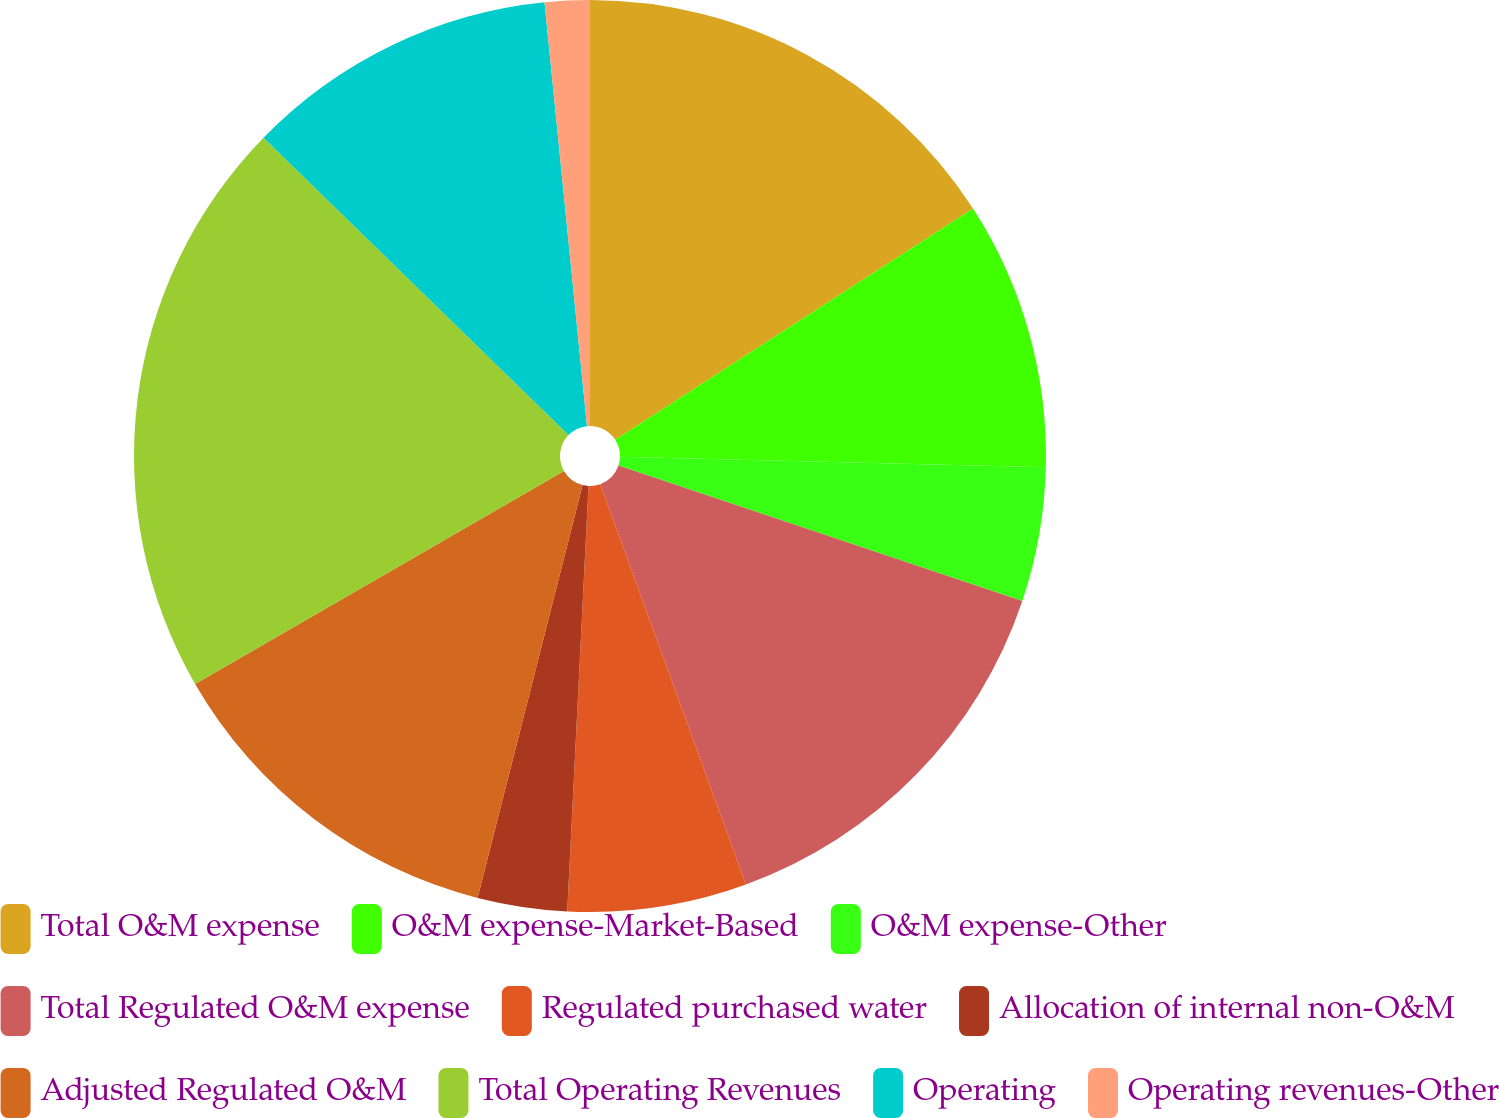<chart> <loc_0><loc_0><loc_500><loc_500><pie_chart><fcel>Total O&M expense<fcel>O&M expense-Market-Based<fcel>O&M expense-Other<fcel>Total Regulated O&M expense<fcel>Regulated purchased water<fcel>Allocation of internal non-O&M<fcel>Adjusted Regulated O&M<fcel>Total Operating Revenues<fcel>Operating<fcel>Operating revenues-Other<nl><fcel>15.87%<fcel>9.52%<fcel>4.76%<fcel>14.29%<fcel>6.35%<fcel>3.17%<fcel>12.7%<fcel>20.63%<fcel>11.11%<fcel>1.59%<nl></chart> 